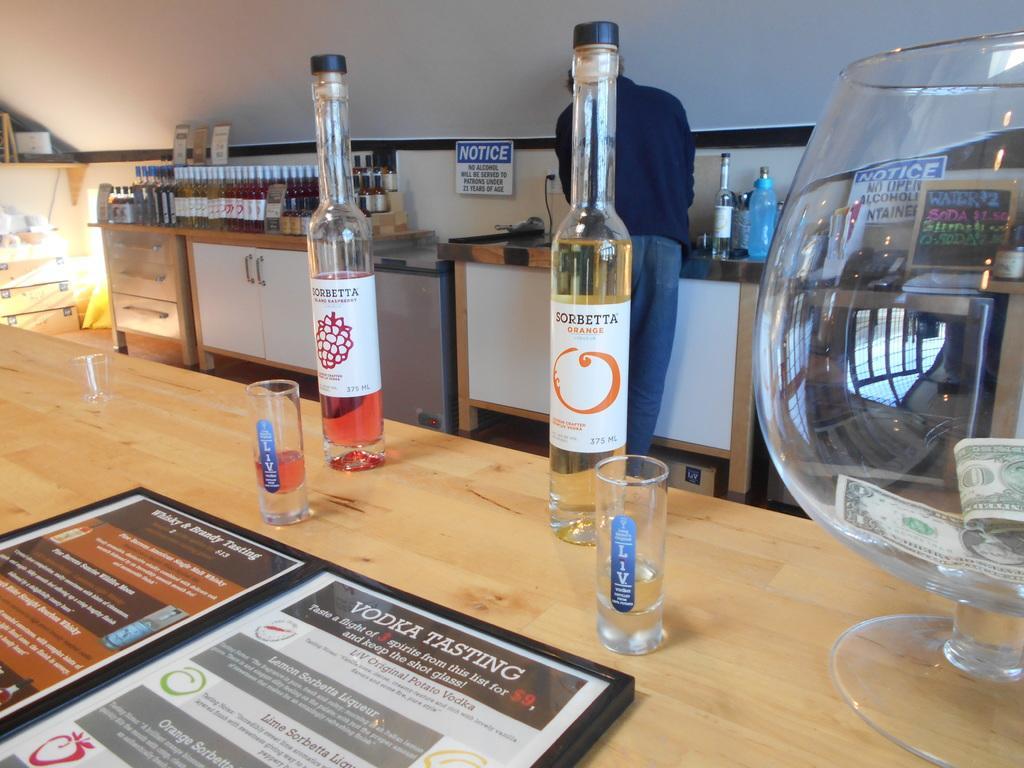Could you give a brief overview of what you see in this image? In this image I can see bottles,glasses and the menu on the table. In the back there is a person standing in front of the wall and there are many wine bottles on the table. 